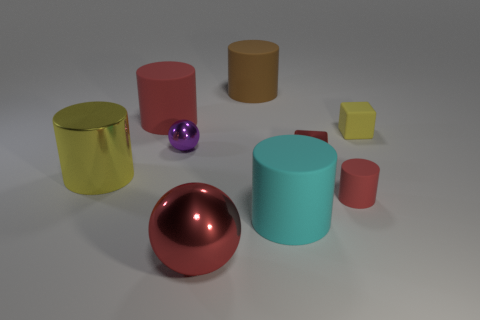Subtract 2 spheres. How many spheres are left? 0 Subtract all tiny matte cylinders. How many cylinders are left? 4 Subtract all red balls. How many balls are left? 1 Subtract all spheres. How many objects are left? 7 Subtract all yellow cylinders. Subtract all blue cubes. How many cylinders are left? 4 Subtract all green cylinders. How many purple cubes are left? 0 Subtract all big things. Subtract all gray metal cylinders. How many objects are left? 4 Add 5 large shiny cylinders. How many large shiny cylinders are left? 6 Add 4 matte cylinders. How many matte cylinders exist? 8 Subtract 0 green cubes. How many objects are left? 9 